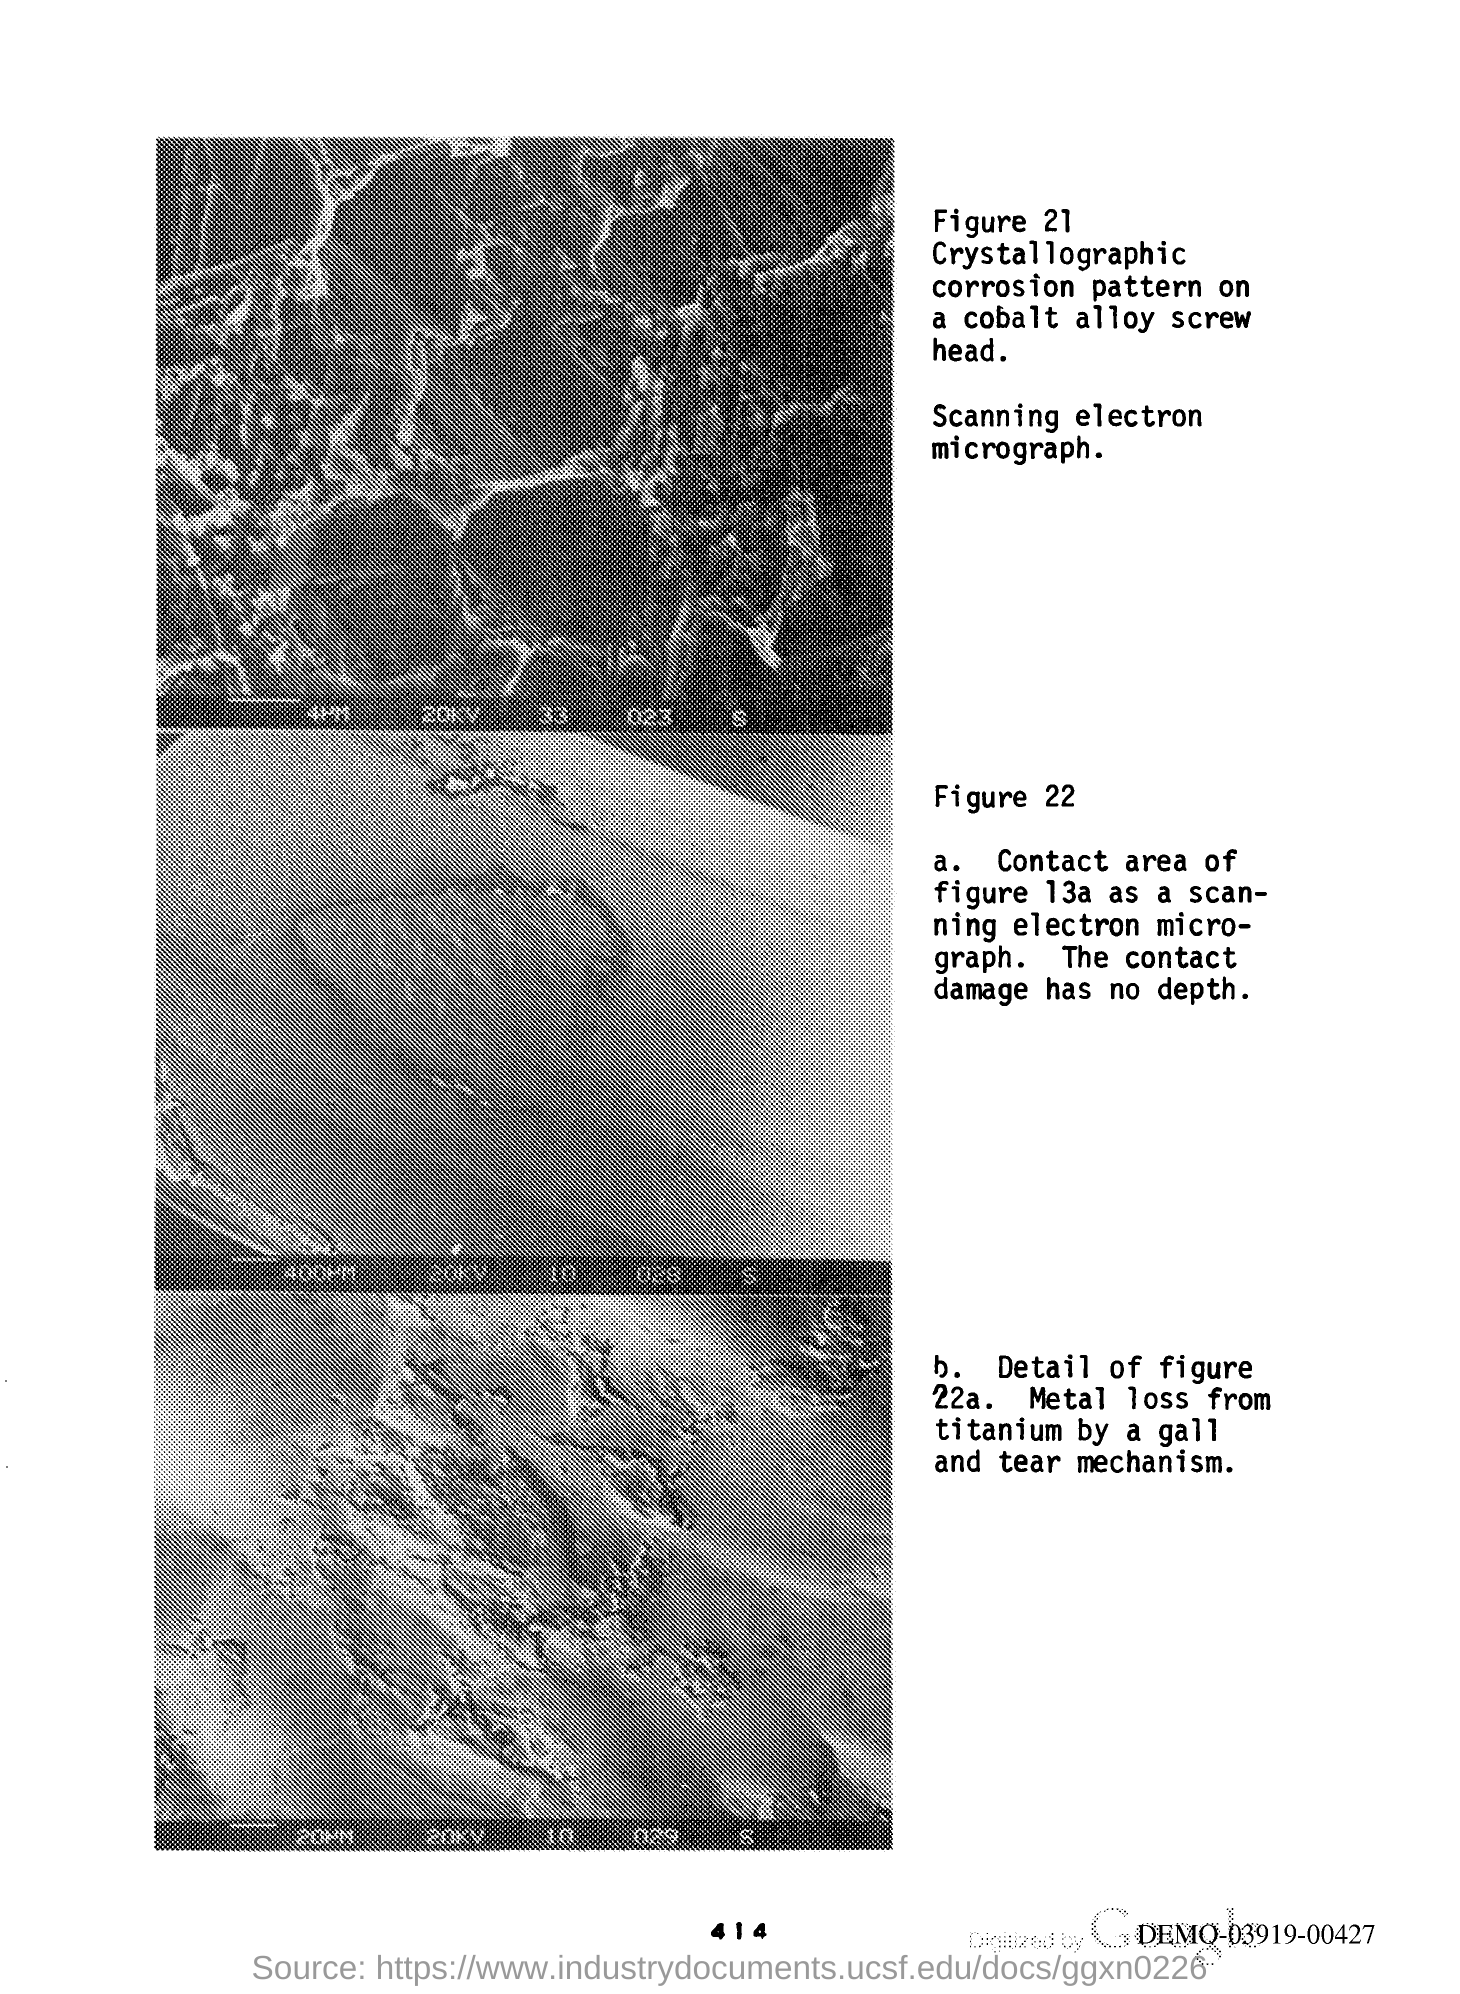What is the Page Number?
Give a very brief answer. 414. 